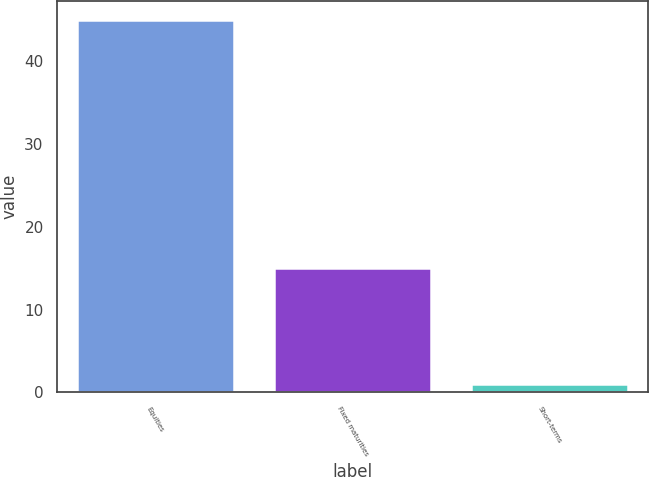<chart> <loc_0><loc_0><loc_500><loc_500><bar_chart><fcel>Equities<fcel>Fixed maturities<fcel>Short-terms<nl><fcel>45<fcel>15<fcel>0.98<nl></chart> 